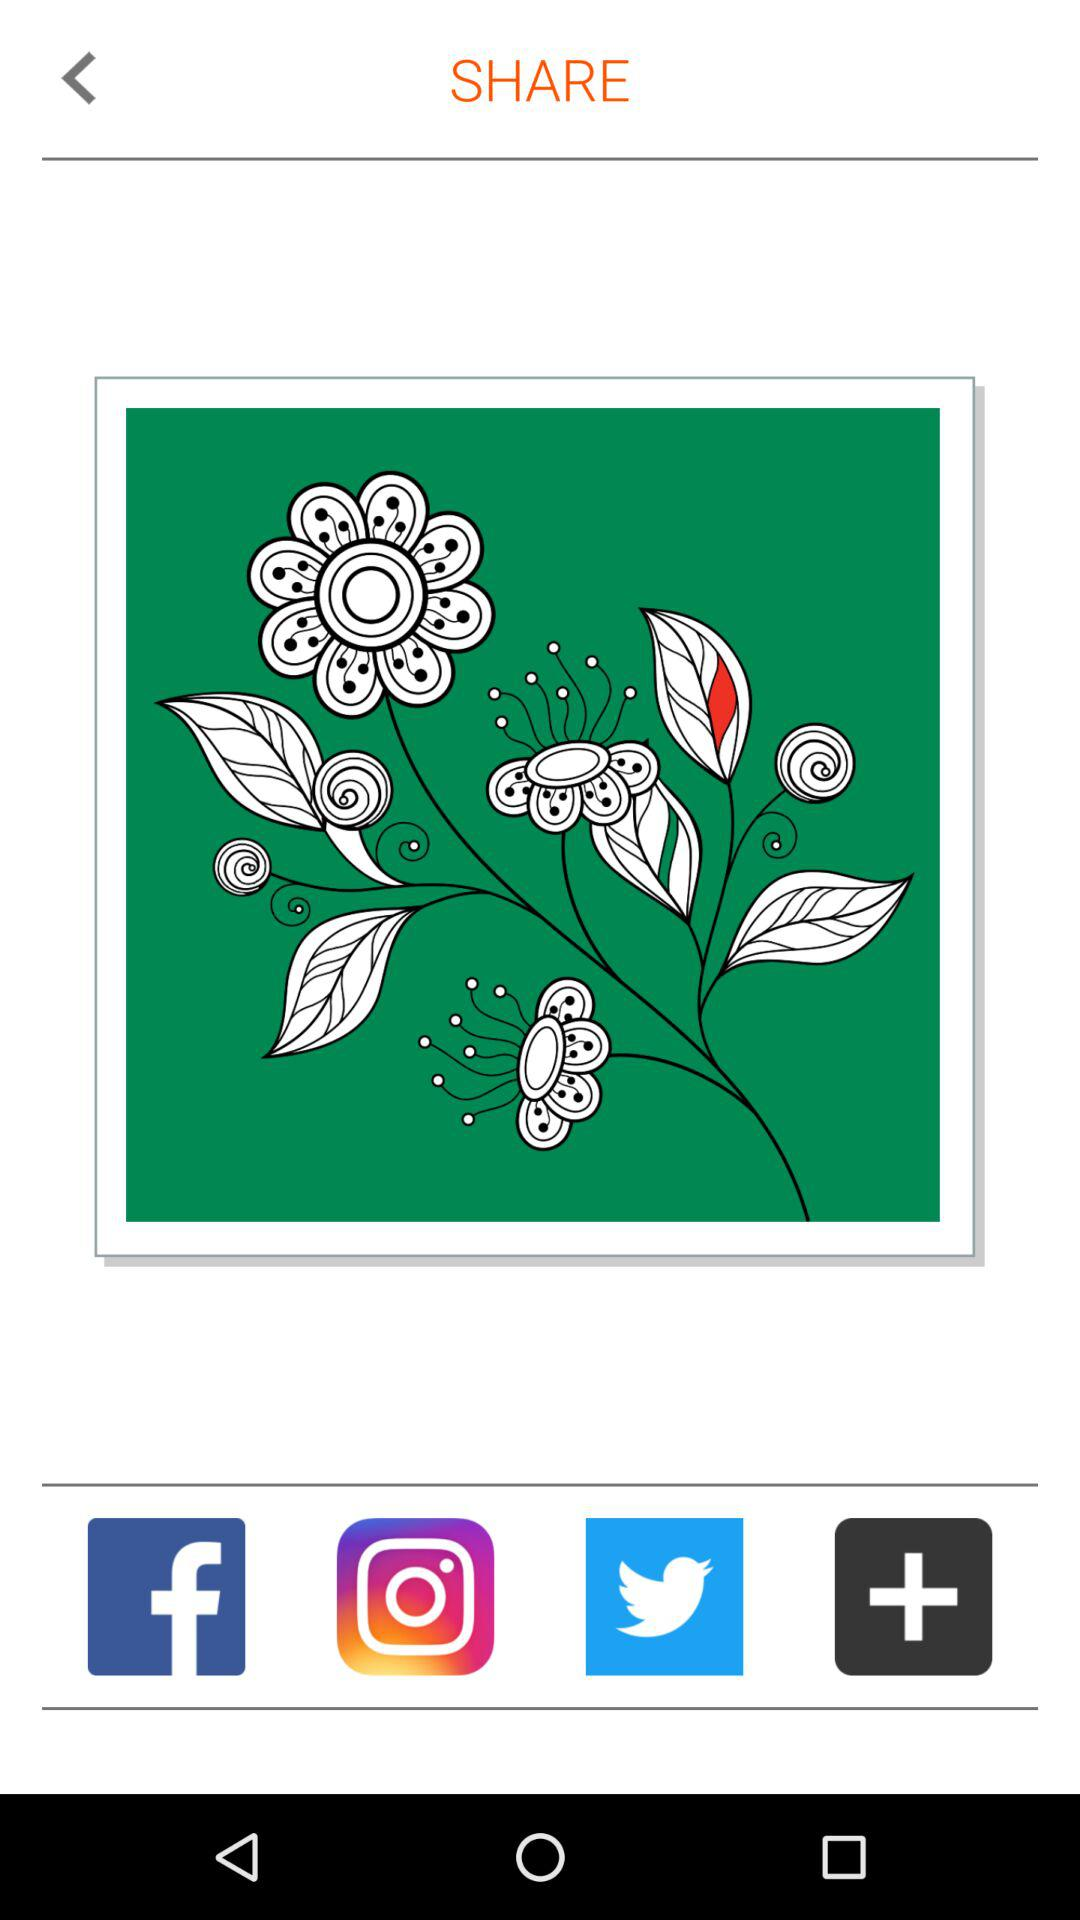Which are the different sharing options? The different sharing options are "Facebook", "Instagram" and "Twitter". 